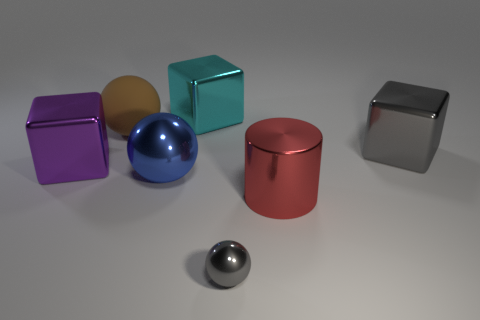Add 2 large blue shiny balls. How many objects exist? 9 Subtract all blocks. How many objects are left? 4 Add 7 large shiny spheres. How many large shiny spheres exist? 8 Subtract 0 green cylinders. How many objects are left? 7 Subtract all big blue spheres. Subtract all gray shiny spheres. How many objects are left? 5 Add 1 purple blocks. How many purple blocks are left? 2 